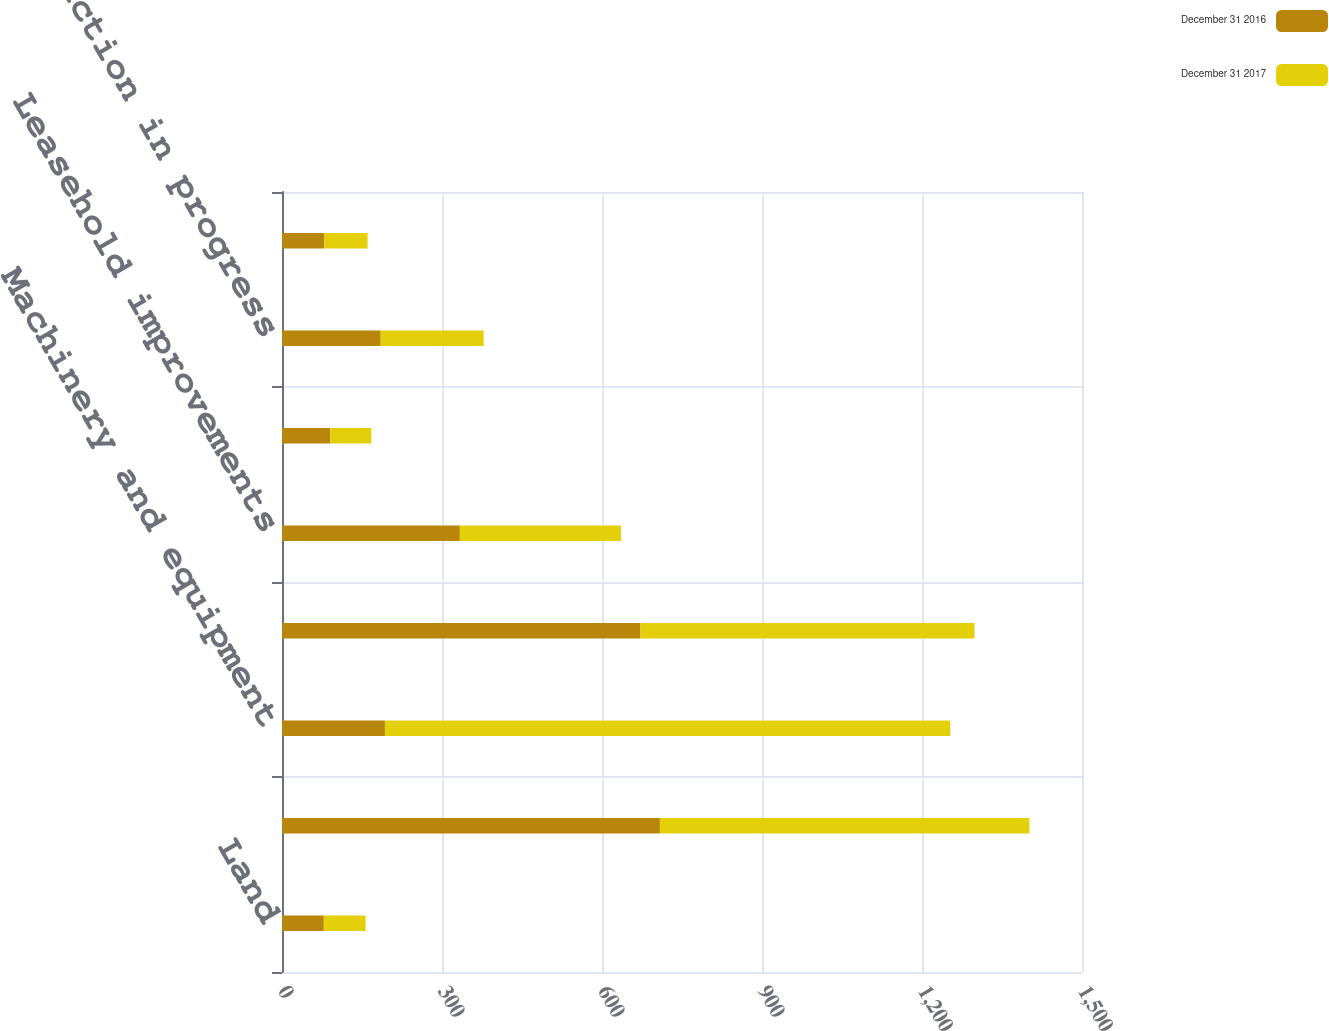Convert chart to OTSL. <chart><loc_0><loc_0><loc_500><loc_500><stacked_bar_chart><ecel><fcel>Land<fcel>Buildings and building<fcel>Machinery and equipment<fcel>Software<fcel>Leasehold improvements<fcel>Furniture and fixtures<fcel>Construction in progress<fcel>Equipment and real estate<nl><fcel>December 31 2016<fcel>78.4<fcel>708.6<fcel>193<fcel>672.2<fcel>333.5<fcel>90.6<fcel>185.1<fcel>79.2<nl><fcel>December 31 2017<fcel>78.4<fcel>692.8<fcel>1060.1<fcel>626.2<fcel>302<fcel>76.9<fcel>193<fcel>81.3<nl></chart> 